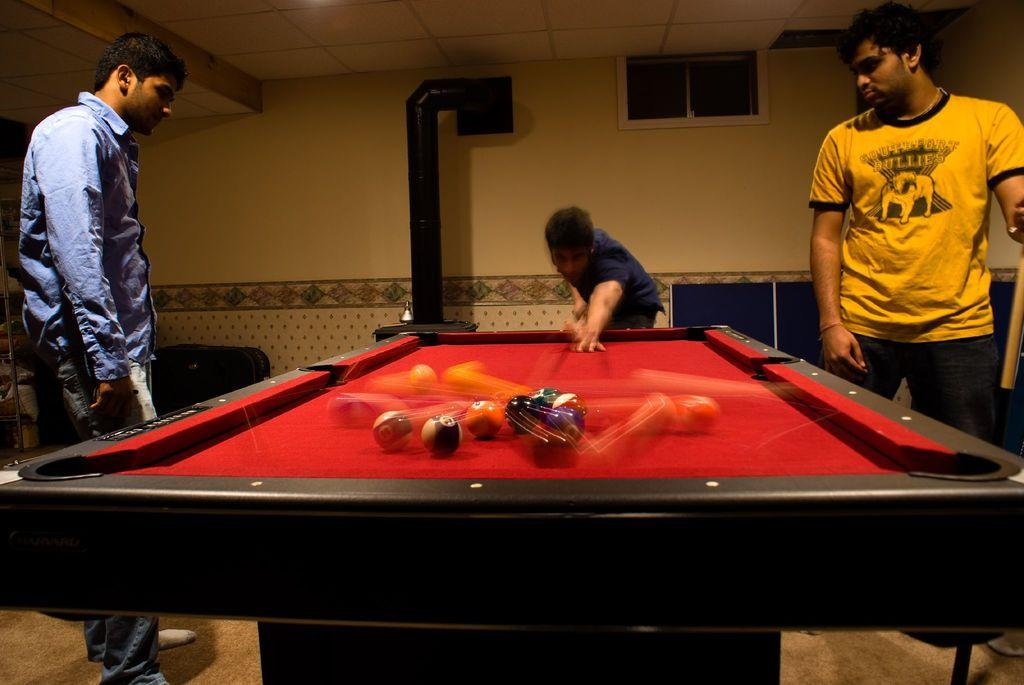What is the setting of the image? The image is taken at a snooker table. What is the person in the image doing? The guy is aiming the ball. What is the guy wearing in the image? The guy is wearing a blue shirt. What can be seen in the background of the image? There is a glass window and a blue color mat in the background. How many sheep are visible in the image? There are no sheep present in the image. What type of kitten is sitting on the snooker table in the image? There is no kitten present on the snooker table or in the image. 